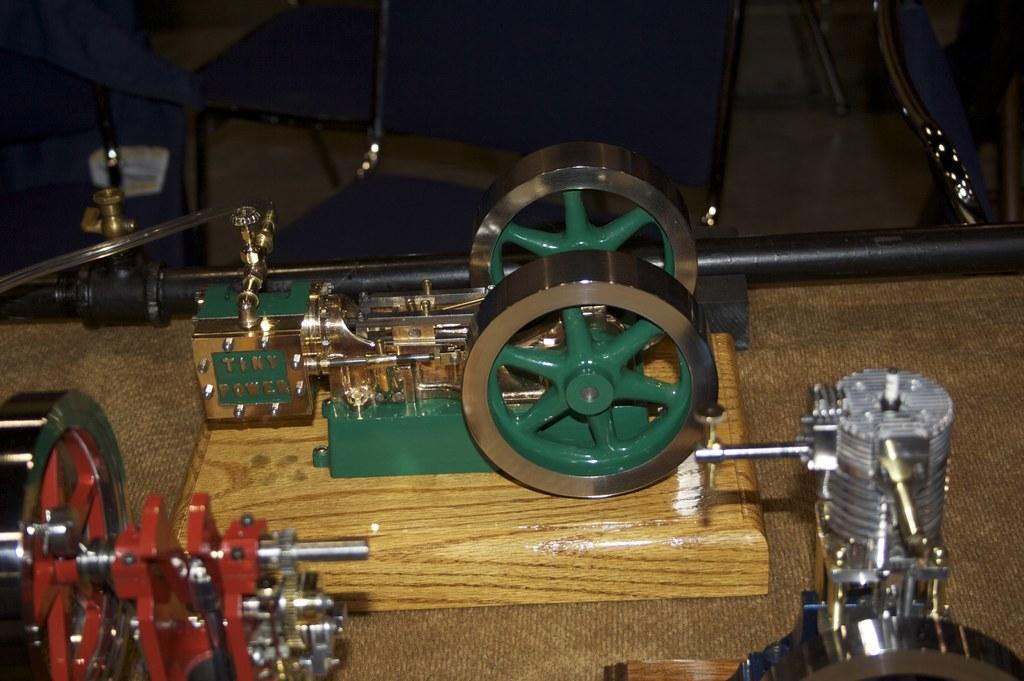What type of machinery is visible in the image? There are metal lathes in the image. Where are the metal lathes located? The metal lathes are placed on a table. What else can be seen in the image besides the metal lathes? There is a bag at the top side of the image. What type of van is shown in the image? There is no van present in the image; it features metal lathes on a table and a bag. What type of attack is being carried out in the image? There is no attack depicted in the image; it shows metal lathes, a table, and a bag. 